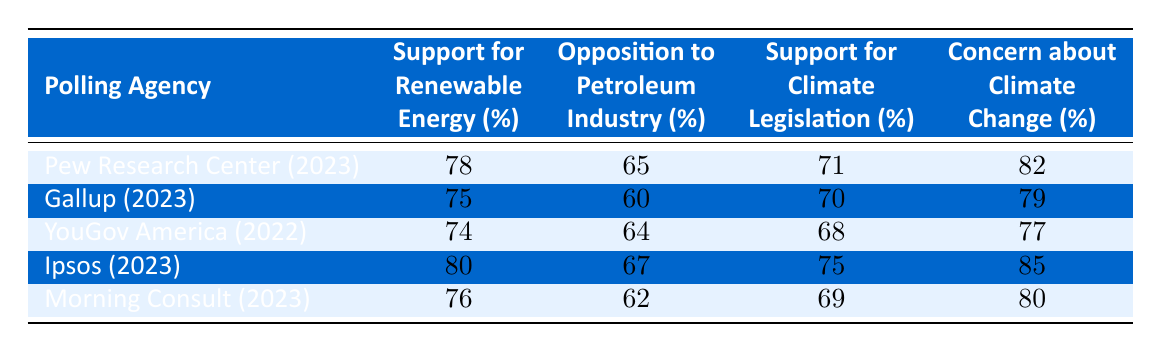What percentage of people surveyed by Pew Research Center support renewable energy? In the table, the data for Pew Research Center under the column "Support for Renewable Energy (%)" shows a value of 78. Thus, the percentage of people supporting renewable energy according to this poll is 78.
Answer: 78 Which polling agency showed the highest concern about climate change? Looking at the "Concern about Climate Change (%)" column, Ipsos has the highest value at 85, meaning they showed the most concern about climate change compared to other polling agencies listed.
Answer: Ipsos What is the average percentage of opposition to the petroleum industry across all agencies listed in 2023? The agencies in 2023 are Pew Research Center, Gallup, Ipsos, and Morning Consult. The opposition percentages are 65, 60, 67, and 62. Sum these values: 65 + 60 + 67 + 62 = 254. Then, divide by 4 (the number of agencies): 254 / 4 = 63.5. Thus, the average opposition percentage is 63.5.
Answer: 63.5 Did YouGov America report a higher support for climate legislation than Gallup? YouGov America's support for climate legislation is 68%, while Gallup's is 70%. Since 68% is less than 70%, the statement is false.
Answer: No Is the support for renewable energy greater than 75% for all polling agencies in 2023? The percentages for 2023 polling agencies are: Pew Research Center (78%), Gallup (75%), Ipsos (80%), and Morning Consult (76%). Since Gallup reports exactly 75%, not all agencies exceed 75%. Therefore, the statement is false.
Answer: No 